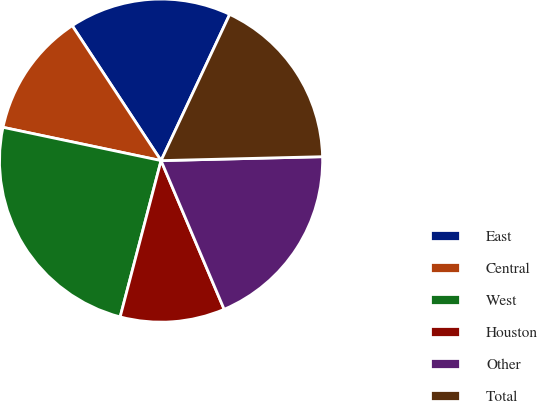<chart> <loc_0><loc_0><loc_500><loc_500><pie_chart><fcel>East<fcel>Central<fcel>West<fcel>Houston<fcel>Other<fcel>Total<nl><fcel>16.25%<fcel>12.43%<fcel>24.23%<fcel>10.46%<fcel>19.0%<fcel>17.63%<nl></chart> 